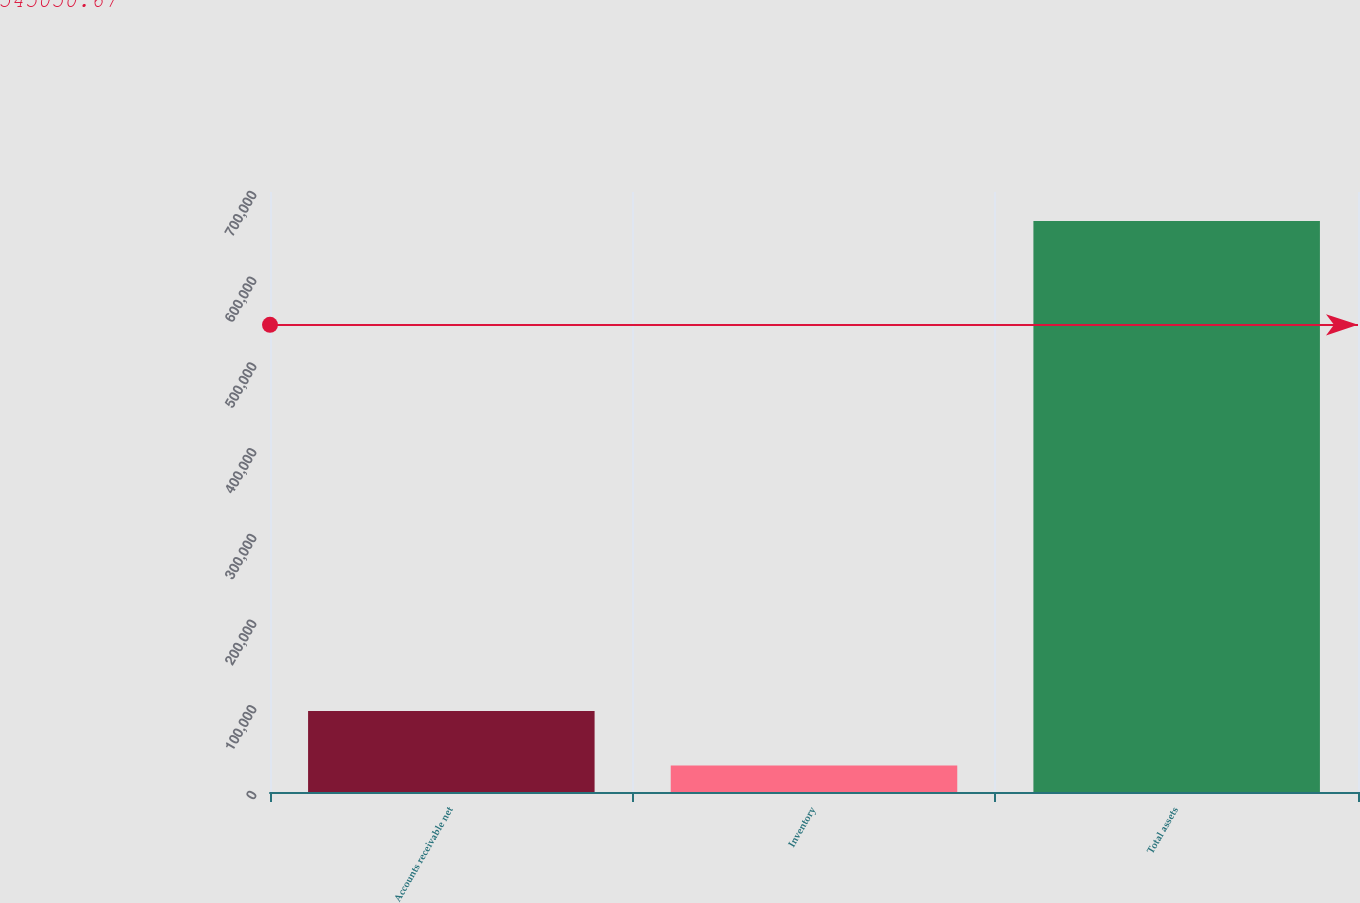<chart> <loc_0><loc_0><loc_500><loc_500><bar_chart><fcel>Accounts receivable net<fcel>Inventory<fcel>Total assets<nl><fcel>94486<fcel>30972<fcel>666112<nl></chart> 